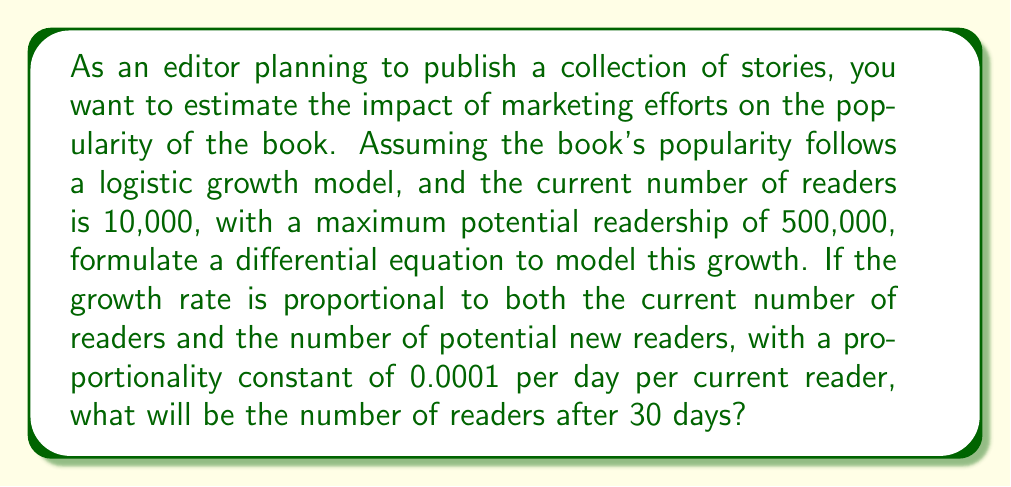Could you help me with this problem? Let's approach this step-by-step:

1) Let $P(t)$ be the number of readers at time $t$ (in days).

2) The logistic growth model is given by the differential equation:

   $$\frac{dP}{dt} = kP(M-P)$$

   where $k$ is the proportionality constant, and $M$ is the maximum potential readership.

3) Given:
   - Initial number of readers: $P(0) = 10,000$
   - Maximum potential readership: $M = 500,000$
   - Proportionality constant: $k = 0.0001$ per day per current reader

4) Substituting these values into the differential equation:

   $$\frac{dP}{dt} = 0.0001P(500,000-P)$$

5) To solve this, we can use the solution to the logistic differential equation:

   $$P(t) = \frac{M}{1 + (\frac{M}{P_0} - 1)e^{-kMt}}$$

   where $P_0$ is the initial population.

6) Substituting our values:

   $$P(t) = \frac{500,000}{1 + (\frac{500,000}{10,000} - 1)e^{-0.0001 \cdot 500,000 \cdot t}}$$

7) Simplify:

   $$P(t) = \frac{500,000}{1 + 49e^{-50t}}$$

8) To find the number of readers after 30 days, we calculate $P(30)$:

   $$P(30) = \frac{500,000}{1 + 49e^{-50 \cdot 30}}$$

9) Evaluate:

   $$P(30) = \frac{500,000}{1 + 49e^{-1500}} \approx 60,571$$

Therefore, after 30 days, the book will have approximately 60,571 readers.
Answer: After 30 days, the book will have approximately 60,571 readers. 